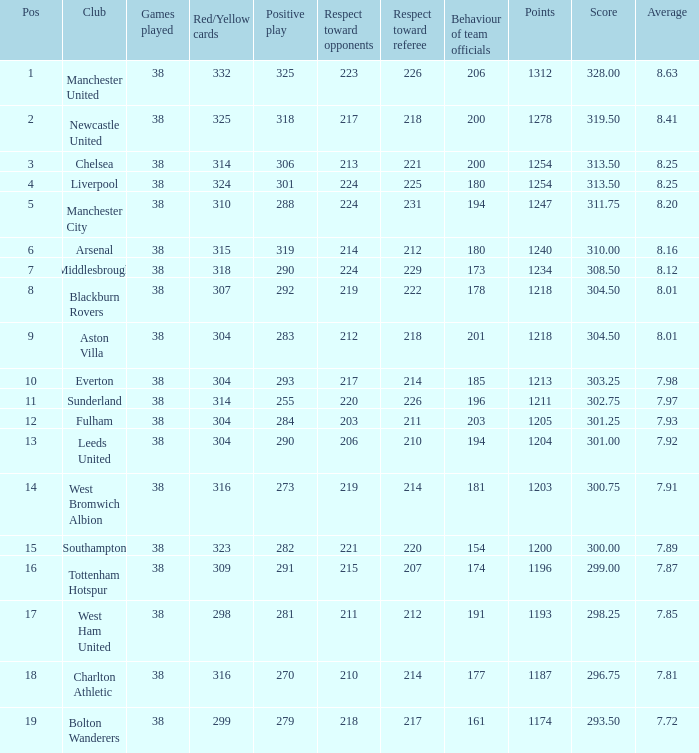Parse the full table. {'header': ['Pos', 'Club', 'Games played', 'Red/Yellow cards', 'Positive play', 'Respect toward opponents', 'Respect toward referee', 'Behaviour of team officials', 'Points', 'Score', 'Average'], 'rows': [['1', 'Manchester United', '38', '332', '325', '223', '226', '206', '1312', '328.00', '8.63'], ['2', 'Newcastle United', '38', '325', '318', '217', '218', '200', '1278', '319.50', '8.41'], ['3', 'Chelsea', '38', '314', '306', '213', '221', '200', '1254', '313.50', '8.25'], ['4', 'Liverpool', '38', '324', '301', '224', '225', '180', '1254', '313.50', '8.25'], ['5', 'Manchester City', '38', '310', '288', '224', '231', '194', '1247', '311.75', '8.20'], ['6', 'Arsenal', '38', '315', '319', '214', '212', '180', '1240', '310.00', '8.16'], ['7', 'Middlesbrough', '38', '318', '290', '224', '229', '173', '1234', '308.50', '8.12'], ['8', 'Blackburn Rovers', '38', '307', '292', '219', '222', '178', '1218', '304.50', '8.01'], ['9', 'Aston Villa', '38', '304', '283', '212', '218', '201', '1218', '304.50', '8.01'], ['10', 'Everton', '38', '304', '293', '217', '214', '185', '1213', '303.25', '7.98'], ['11', 'Sunderland', '38', '314', '255', '220', '226', '196', '1211', '302.75', '7.97'], ['12', 'Fulham', '38', '304', '284', '203', '211', '203', '1205', '301.25', '7.93'], ['13', 'Leeds United', '38', '304', '290', '206', '210', '194', '1204', '301.00', '7.92'], ['14', 'West Bromwich Albion', '38', '316', '273', '219', '214', '181', '1203', '300.75', '7.91'], ['15', 'Southampton', '38', '323', '282', '221', '220', '154', '1200', '300.00', '7.89'], ['16', 'Tottenham Hotspur', '38', '309', '291', '215', '207', '174', '1196', '299.00', '7.87'], ['17', 'West Ham United', '38', '298', '281', '211', '212', '191', '1193', '298.25', '7.85'], ['18', 'Charlton Athletic', '38', '316', '270', '210', '214', '177', '1187', '296.75', '7.81'], ['19', 'Bolton Wanderers', '38', '299', '279', '218', '217', '161', '1174', '293.50', '7.72']]} List the factors that contribute to 212 respect for adversaries. 1218.0. 